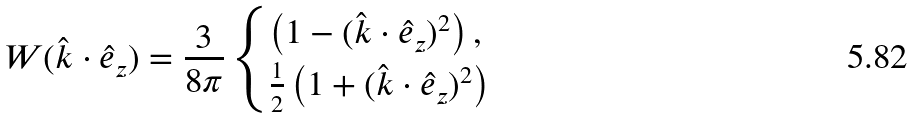<formula> <loc_0><loc_0><loc_500><loc_500>W ( \hat { k } \cdot \hat { e } _ { z } ) = \frac { 3 } { 8 \pi } \begin{cases} \left ( 1 - ( \hat { k } \cdot \hat { e } _ { z } ) ^ { 2 } \right ) , \\ \frac { 1 } { 2 } \left ( 1 + ( \hat { k } \cdot \hat { e } _ { z } ) ^ { 2 } \right ) \end{cases}</formula> 